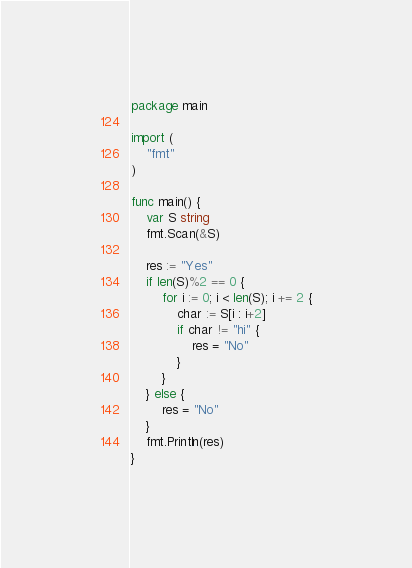<code> <loc_0><loc_0><loc_500><loc_500><_Go_>package main

import (
	"fmt"
)

func main() {
	var S string
	fmt.Scan(&S)

	res := "Yes"
	if len(S)%2 == 0 {
		for i := 0; i < len(S); i += 2 {
			char := S[i : i+2]
			if char != "hi" {
				res = "No"
			}
		}
	} else {
		res = "No"
	}
	fmt.Println(res)
}
</code> 